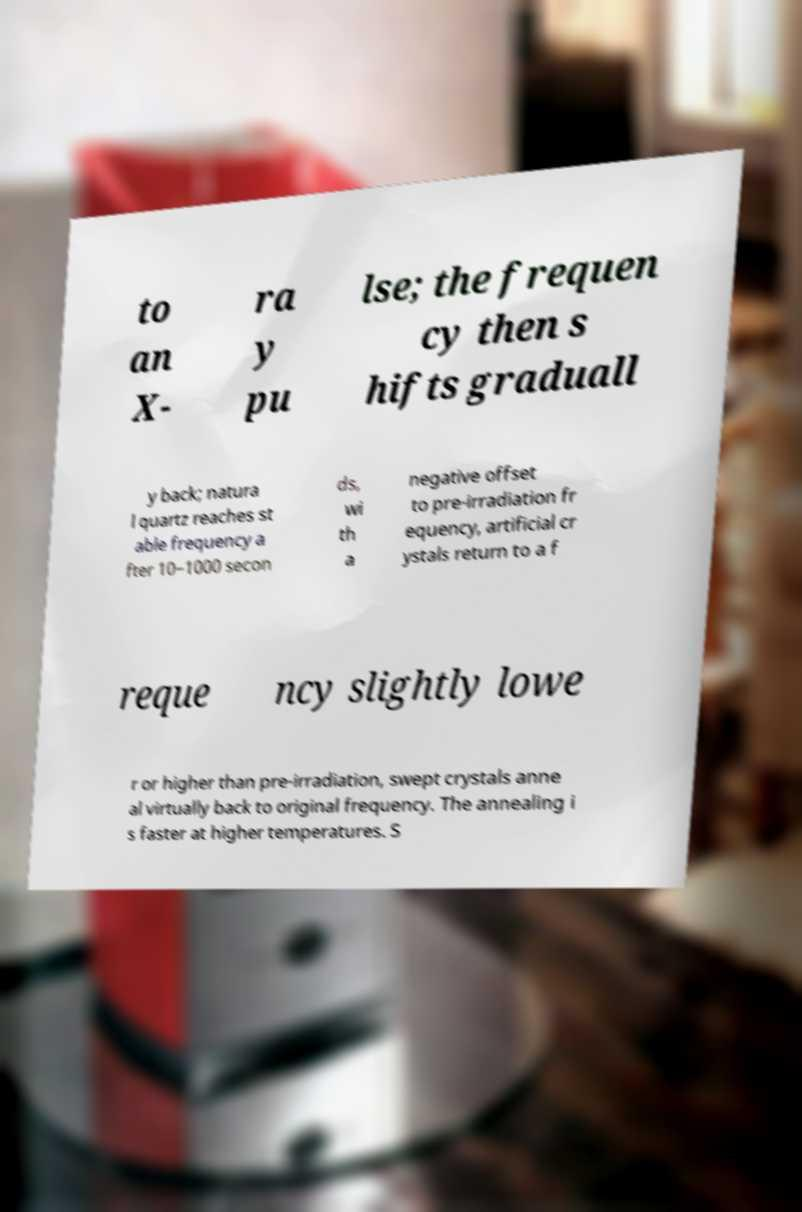Could you extract and type out the text from this image? to an X- ra y pu lse; the frequen cy then s hifts graduall y back; natura l quartz reaches st able frequency a fter 10–1000 secon ds, wi th a negative offset to pre-irradiation fr equency, artificial cr ystals return to a f reque ncy slightly lowe r or higher than pre-irradiation, swept crystals anne al virtually back to original frequency. The annealing i s faster at higher temperatures. S 